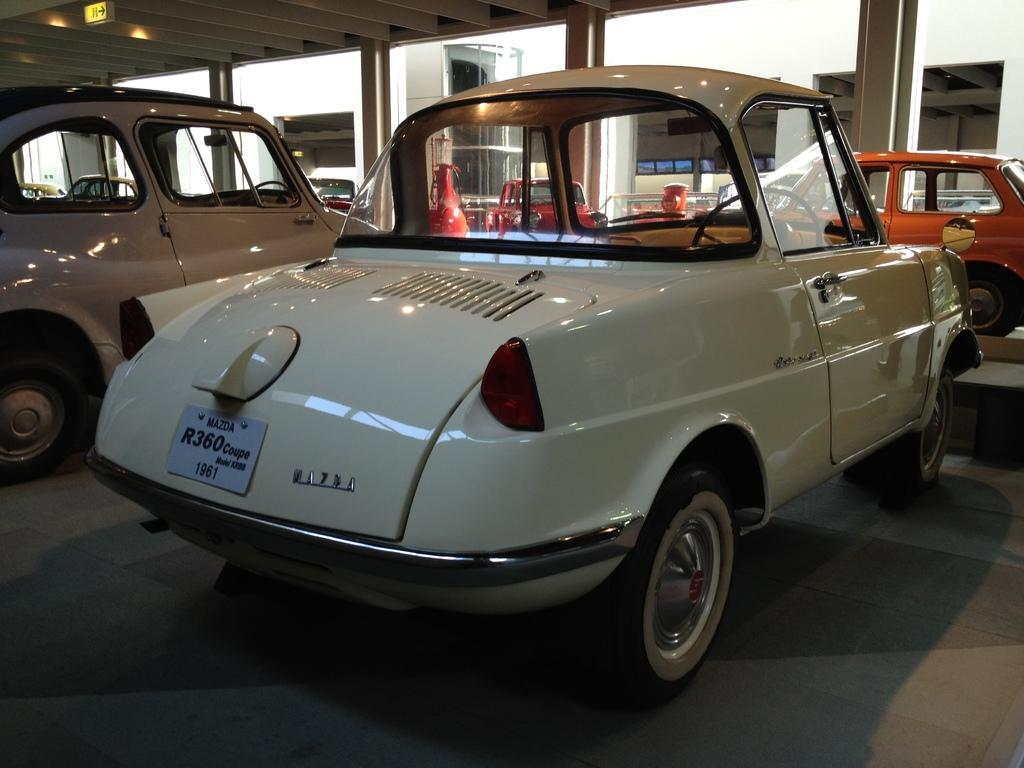What types of objects can be seen in the image? There are vehicles, a board, and lights present in the image. What part of the structure is visible in the image? The floor, pillars, roof, and walls are visible in the image. What type of credit can be seen on the board in the image? There is no credit mentioned or visible on the board in the image. What can be used to store the linen in the image? There is no mention or presence of linen in the image. 